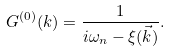<formula> <loc_0><loc_0><loc_500><loc_500>G ^ { ( 0 ) } ( k ) = \frac { 1 } { i \omega _ { n } - \xi ( \vec { k } ) } .</formula> 